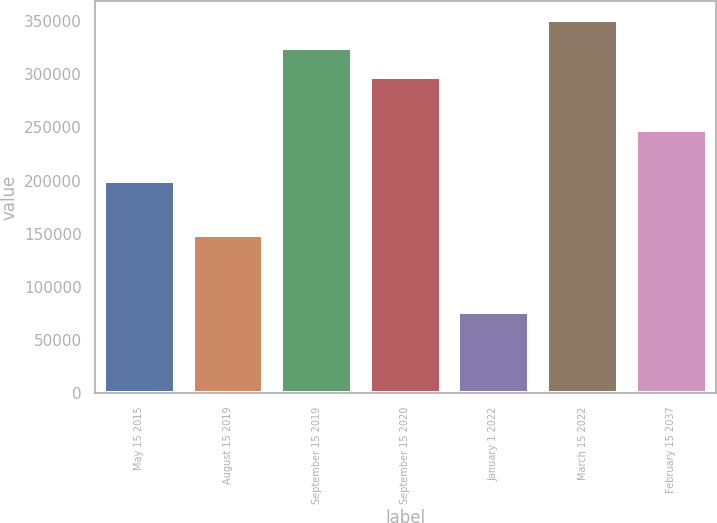<chart> <loc_0><loc_0><loc_500><loc_500><bar_chart><fcel>May 15 2015<fcel>August 15 2019<fcel>September 15 2019<fcel>September 15 2020<fcel>January 1 2022<fcel>March 15 2022<fcel>February 15 2037<nl><fcel>199559<fcel>149057<fcel>324421<fcel>297401<fcel>75962<fcel>351441<fcel>247347<nl></chart> 